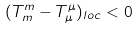<formula> <loc_0><loc_0><loc_500><loc_500>( T ^ { m } _ { m } - T ^ { \mu } _ { \mu } ) _ { l o c } < 0</formula> 